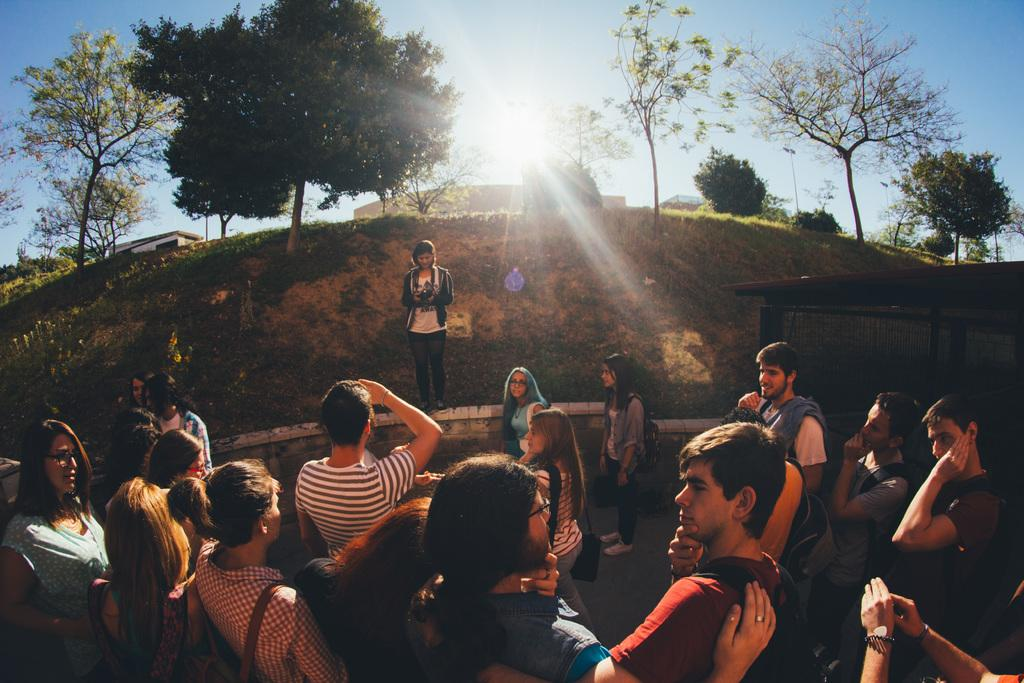How many people are in the image? There is a group of people standing in the image, but the exact number cannot be determined from the provided facts. What can be seen in the background of the image? There is grass, trees, and the sky visible in the background of the image. What type of clam can be seen holding an icicle in the image? There is no clam or icicle present in the image. How does the group of people maintain their grip on the grass in the image? The provided facts do not mention anything about the group of people gripping the grass, so we cannot answer this question. 